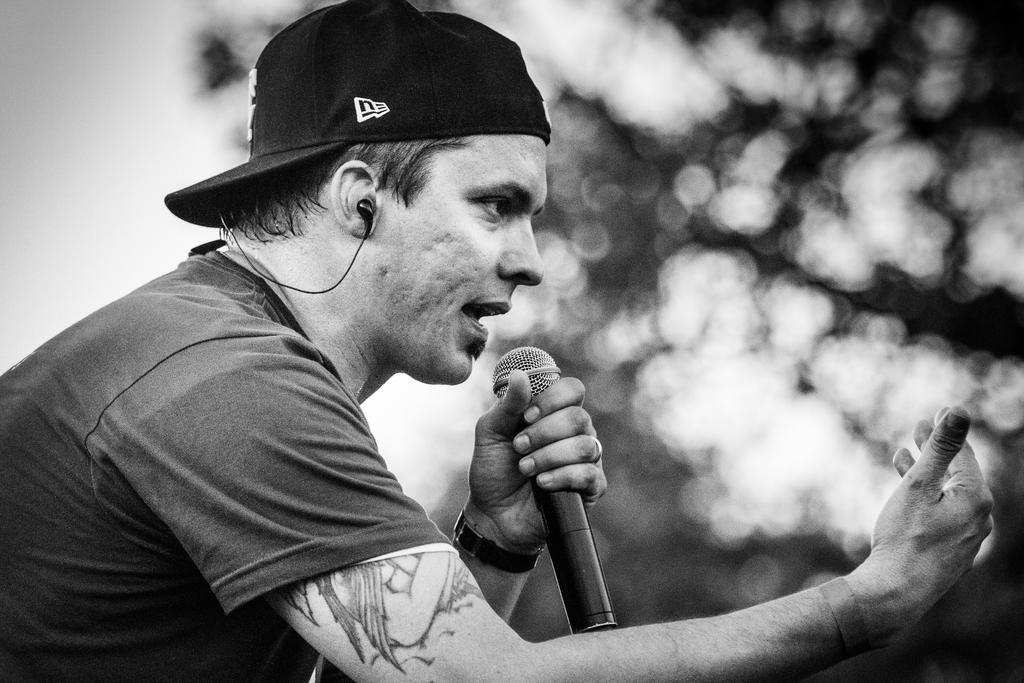Describe this image in one or two sentences. In this picture we can find a man with a cap and T-shirt and he is holding a microphone and talking something. In the background we can find some trees lightly. 